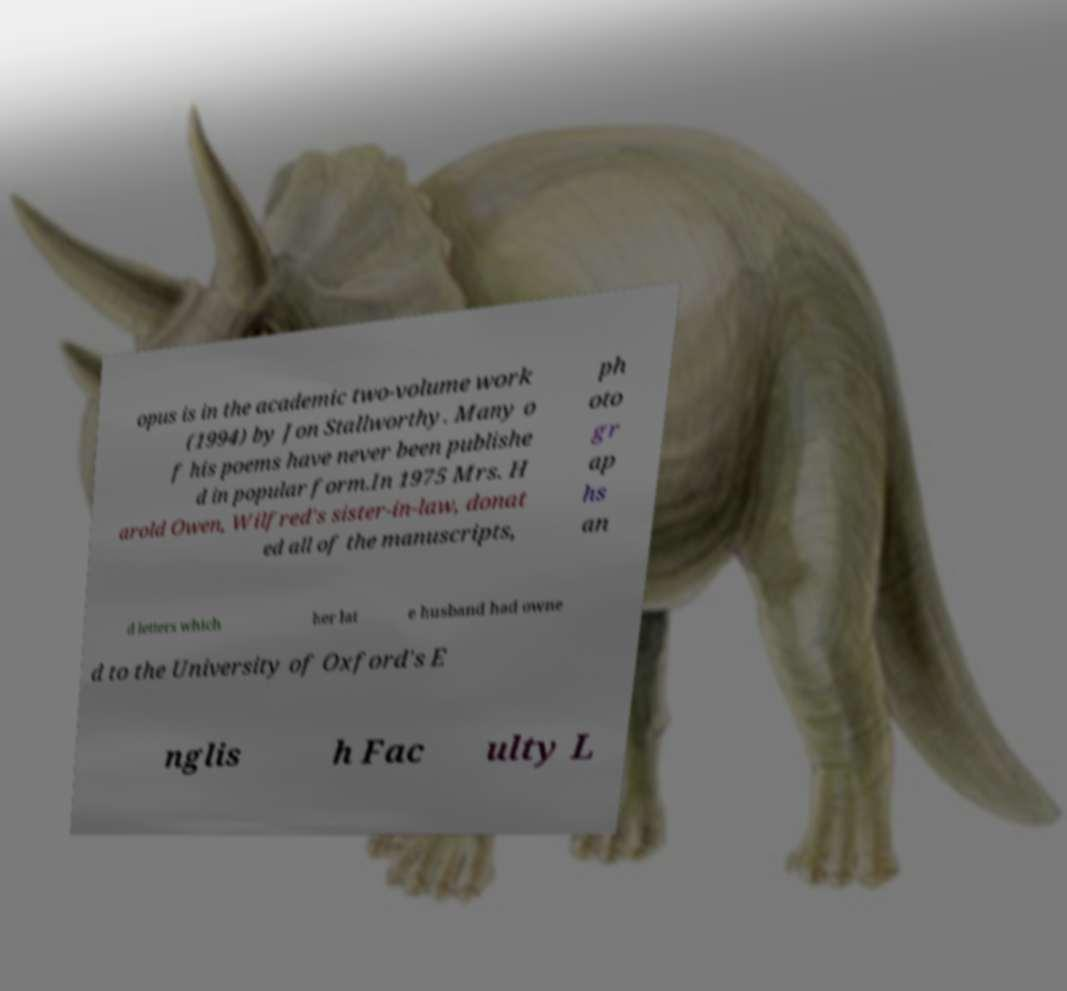Can you read and provide the text displayed in the image?This photo seems to have some interesting text. Can you extract and type it out for me? opus is in the academic two-volume work (1994) by Jon Stallworthy. Many o f his poems have never been publishe d in popular form.In 1975 Mrs. H arold Owen, Wilfred's sister-in-law, donat ed all of the manuscripts, ph oto gr ap hs an d letters which her lat e husband had owne d to the University of Oxford's E nglis h Fac ulty L 